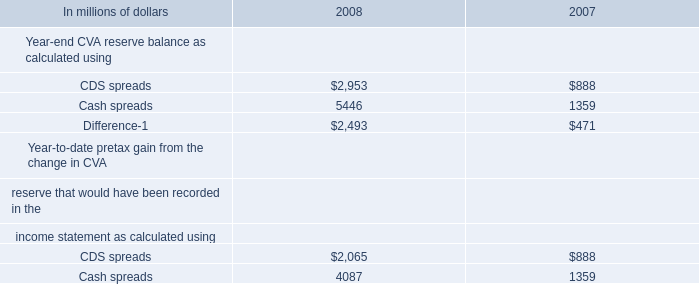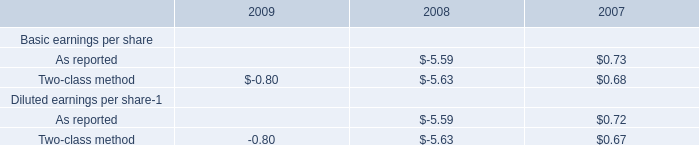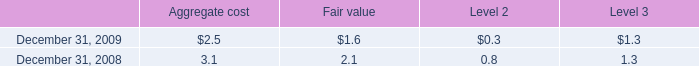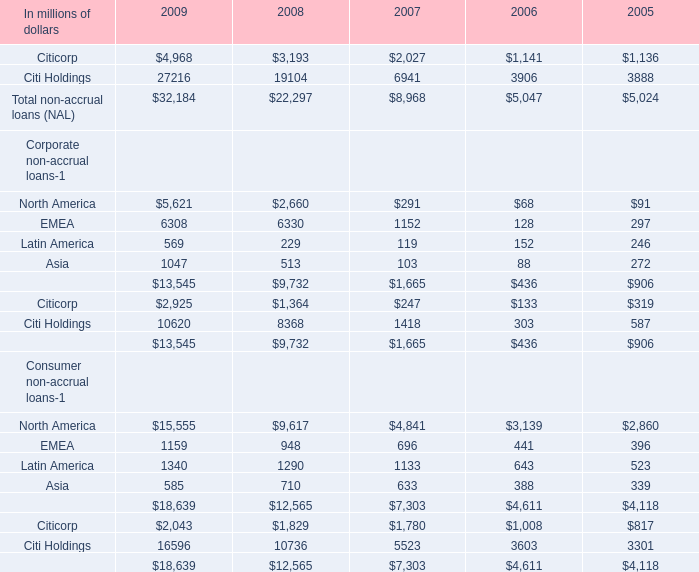What is the sum of Citicorp in 2009 ? (in million) 
Computations: ((4968 + 2925) + 2043)
Answer: 9936.0. 